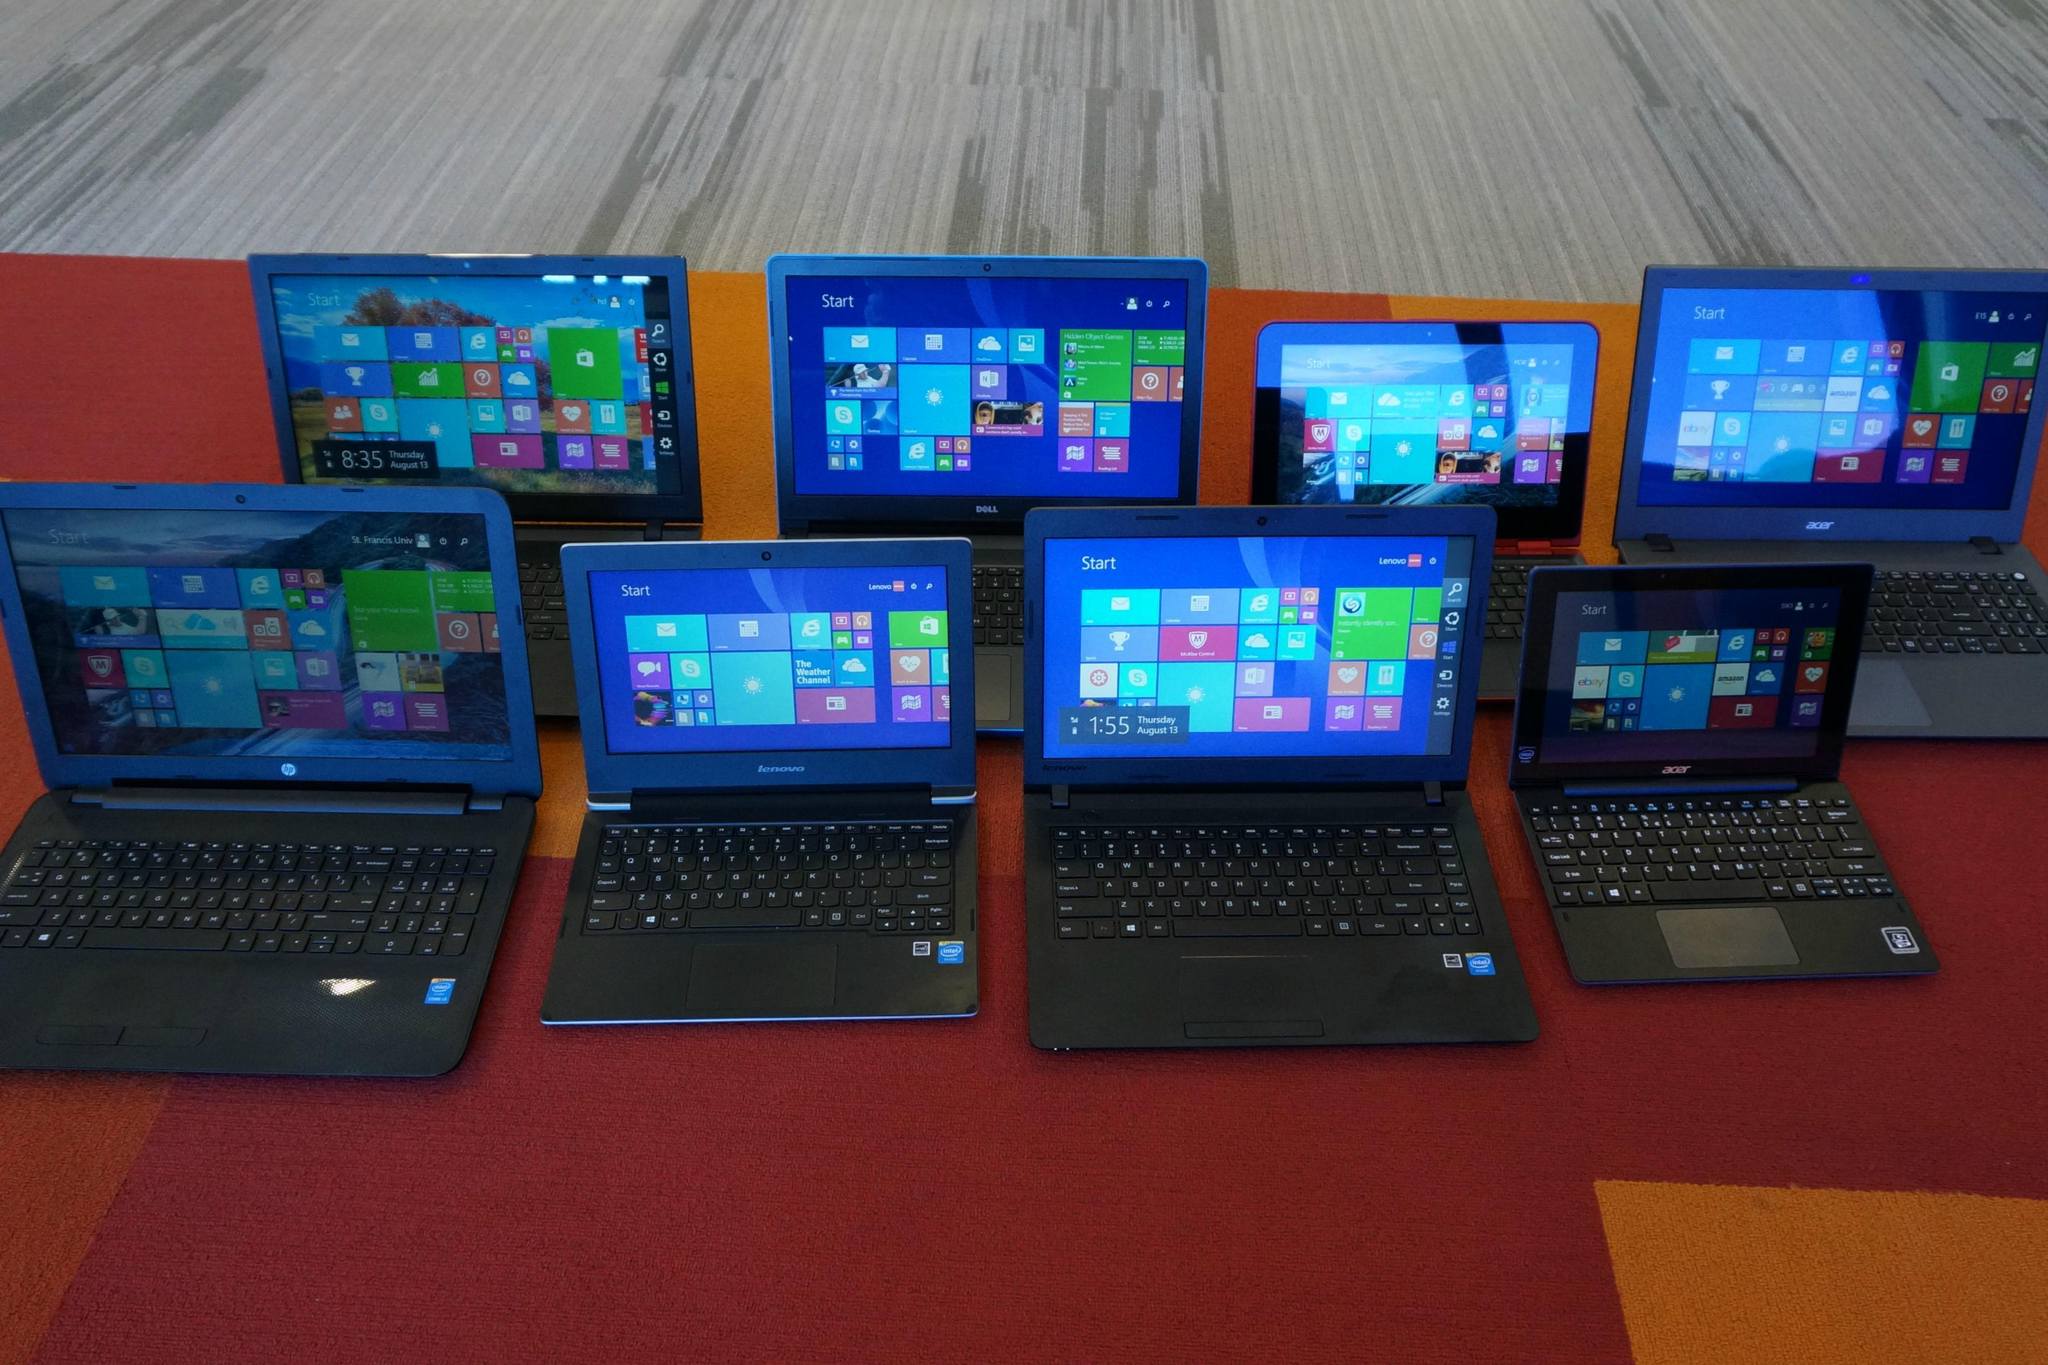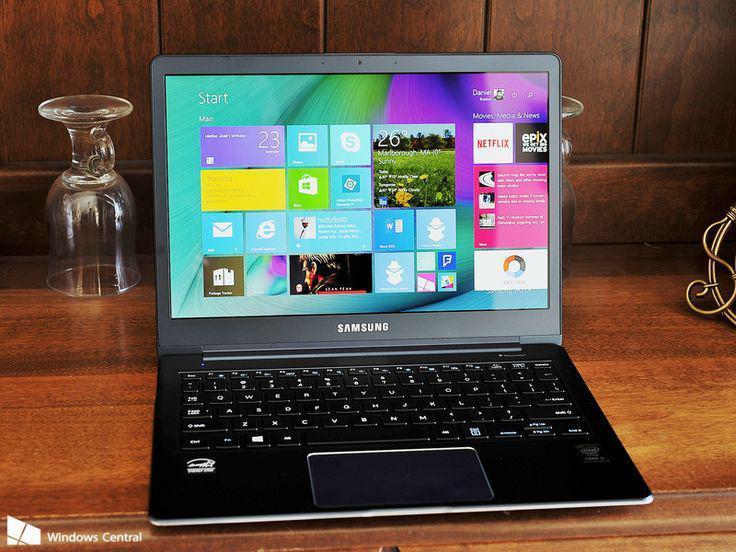The first image is the image on the left, the second image is the image on the right. Considering the images on both sides, is "One of the pictures has more than one laptop." valid? Answer yes or no. Yes. The first image is the image on the left, the second image is the image on the right. Examine the images to the left and right. Is the description "There are more computers in the image on the left." accurate? Answer yes or no. Yes. 